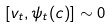<formula> <loc_0><loc_0><loc_500><loc_500>\left [ v _ { t } , \psi _ { t } ( c ) \right ] \sim 0</formula> 